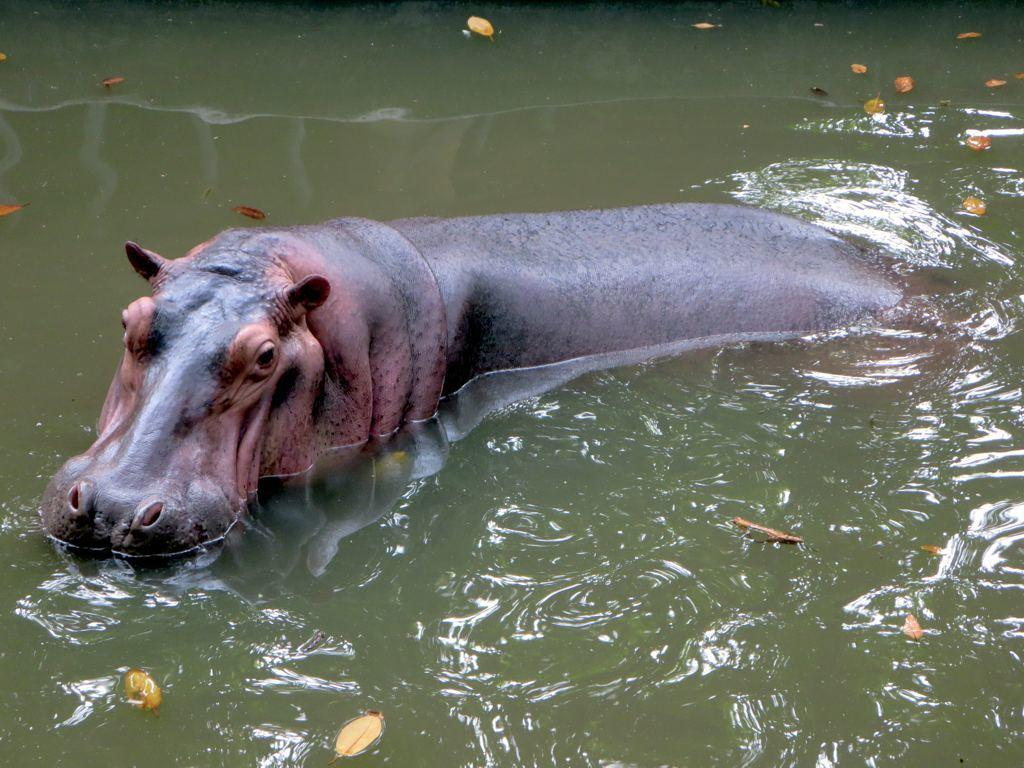What animal is in the image? There is a hippopotamus in the image. Where is the hippopotamus located? The hippopotamus is in the water. What is the color of the water? The water is green in color. What else can be seen in the water? There are dried leaves in the water. What type of playground equipment can be seen in the image? There is no playground equipment present in the image; it features a hippopotamus in green water with dried leaves. 